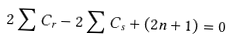Convert formula to latex. <formula><loc_0><loc_0><loc_500><loc_500>2 \sum C _ { r } - 2 \sum C _ { s } + ( 2 n + 1 ) = 0</formula> 